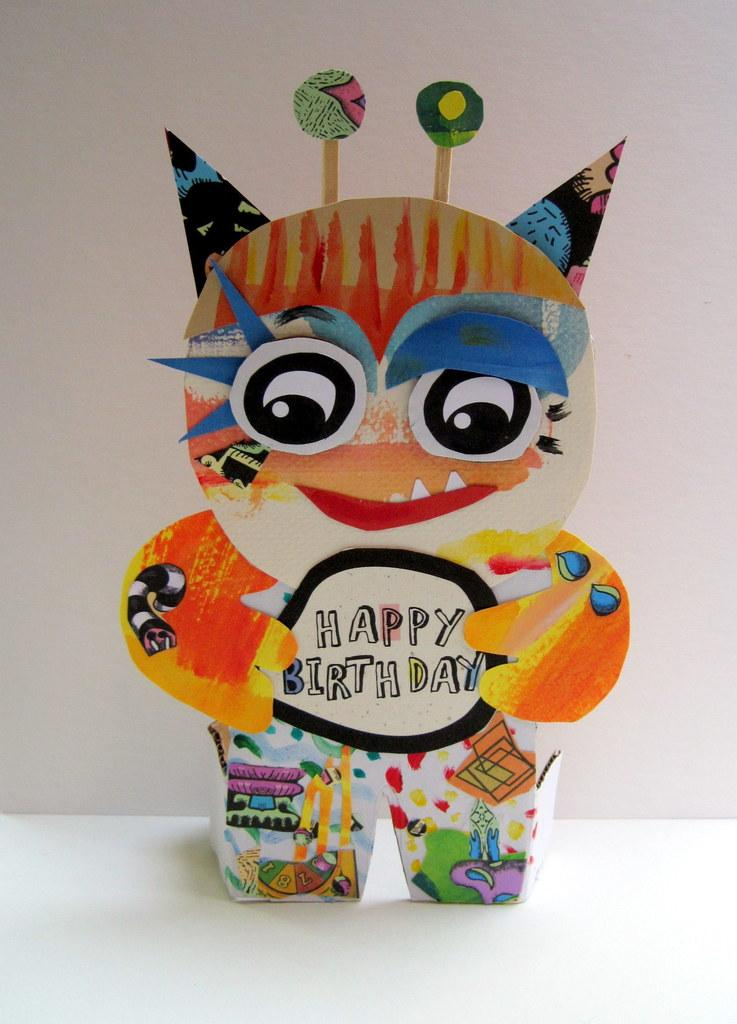What object is on the ground in the image? There is a toy on the ground. What can be seen in the background of the image? There is a wall visible in the background of the image. What shape is the impulse taking in the image? There is no impulse present in the image, and therefore no shape can be attributed to it. 